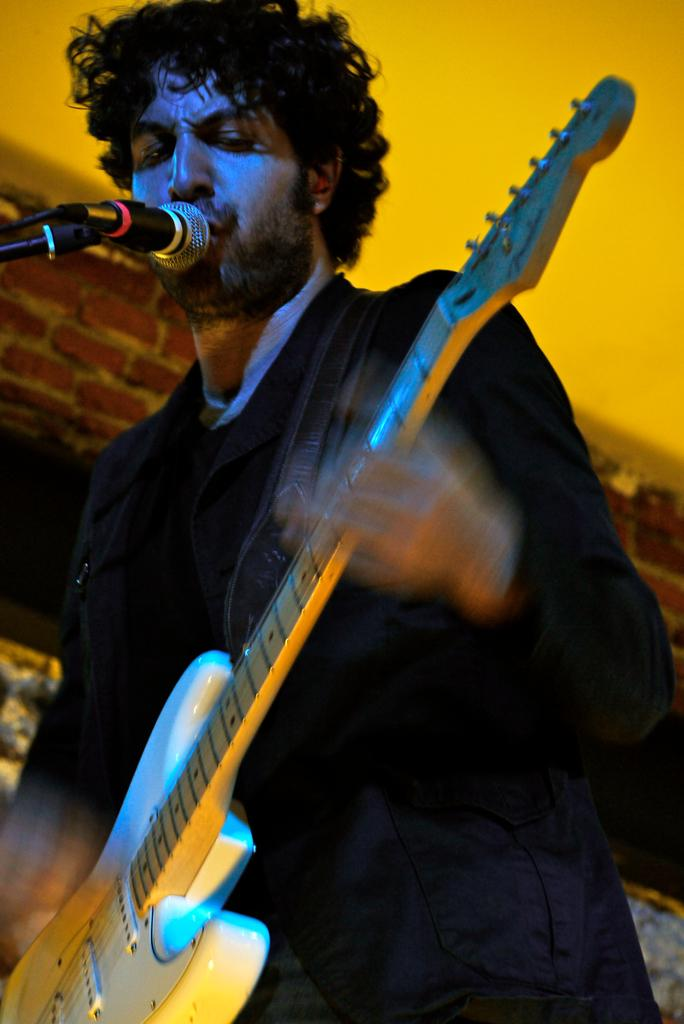What is the person in the image doing? The person is holding a guitar. What object is in front of the person? There is a microphone in front of the person. What can be seen in the background of the image? There is a wall in the background of the image. What type of whip is the person using to play the guitar in the image? There is no whip present in the image; the person is playing the guitar with their hands. 